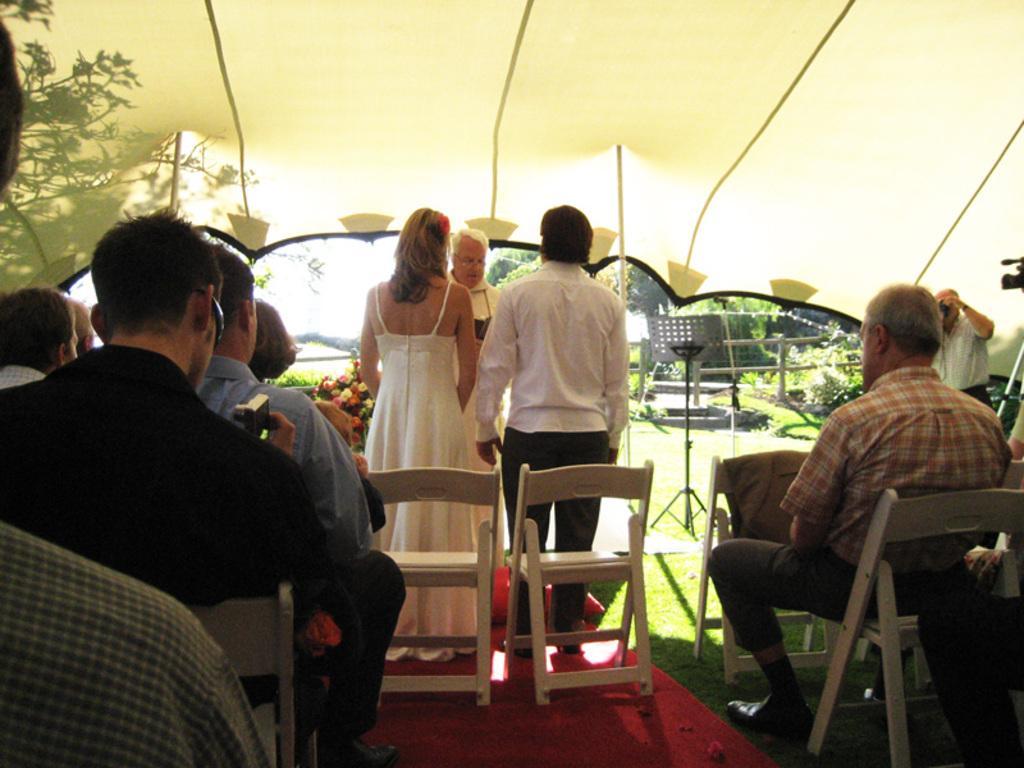In one or two sentences, can you explain what this image depicts? In the image we can see there are people sitting and some of them are standing, they are wearing clothes and some of them are wearing shoes. We can even see there are chairs and the red carpet. We can even see there are flowers, fence, grass, plants and trees. We can even see the tent and there is a person holding a camera in hands. 